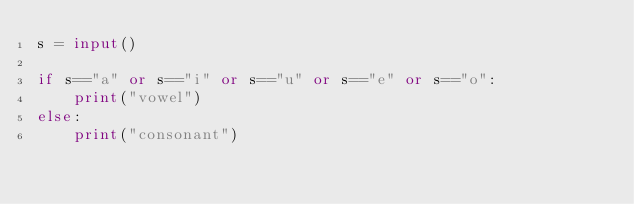Convert code to text. <code><loc_0><loc_0><loc_500><loc_500><_Python_>s = input()

if s=="a" or s=="i" or s=="u" or s=="e" or s=="o":
    print("vowel")
else:
    print("consonant")</code> 